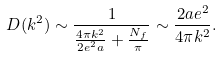<formula> <loc_0><loc_0><loc_500><loc_500>D ( k ^ { 2 } ) \sim \frac { 1 } { \frac { 4 \pi k ^ { 2 } } { 2 e ^ { 2 } a } + \frac { N _ { f } } { \pi } } \sim \frac { 2 a e ^ { 2 } } { 4 \pi k ^ { 2 } } .</formula> 